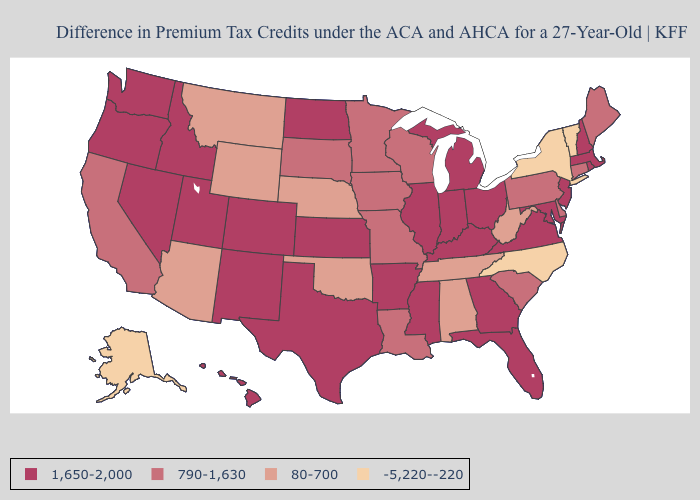Does the map have missing data?
Write a very short answer. No. What is the highest value in states that border Wisconsin?
Quick response, please. 1,650-2,000. Which states have the lowest value in the USA?
Keep it brief. Alaska, New York, North Carolina, Vermont. Among the states that border Connecticut , which have the highest value?
Be succinct. Massachusetts, Rhode Island. Does Oklahoma have the highest value in the South?
Answer briefly. No. What is the lowest value in the USA?
Give a very brief answer. -5,220--220. What is the value of Texas?
Short answer required. 1,650-2,000. Does Texas have the same value as Tennessee?
Short answer required. No. Does Alabama have a higher value than Minnesota?
Be succinct. No. How many symbols are there in the legend?
Short answer required. 4. What is the highest value in states that border Mississippi?
Keep it brief. 1,650-2,000. How many symbols are there in the legend?
Concise answer only. 4. What is the value of Kentucky?
Answer briefly. 1,650-2,000. Name the states that have a value in the range 80-700?
Quick response, please. Alabama, Arizona, Montana, Nebraska, Oklahoma, Tennessee, West Virginia, Wyoming. 